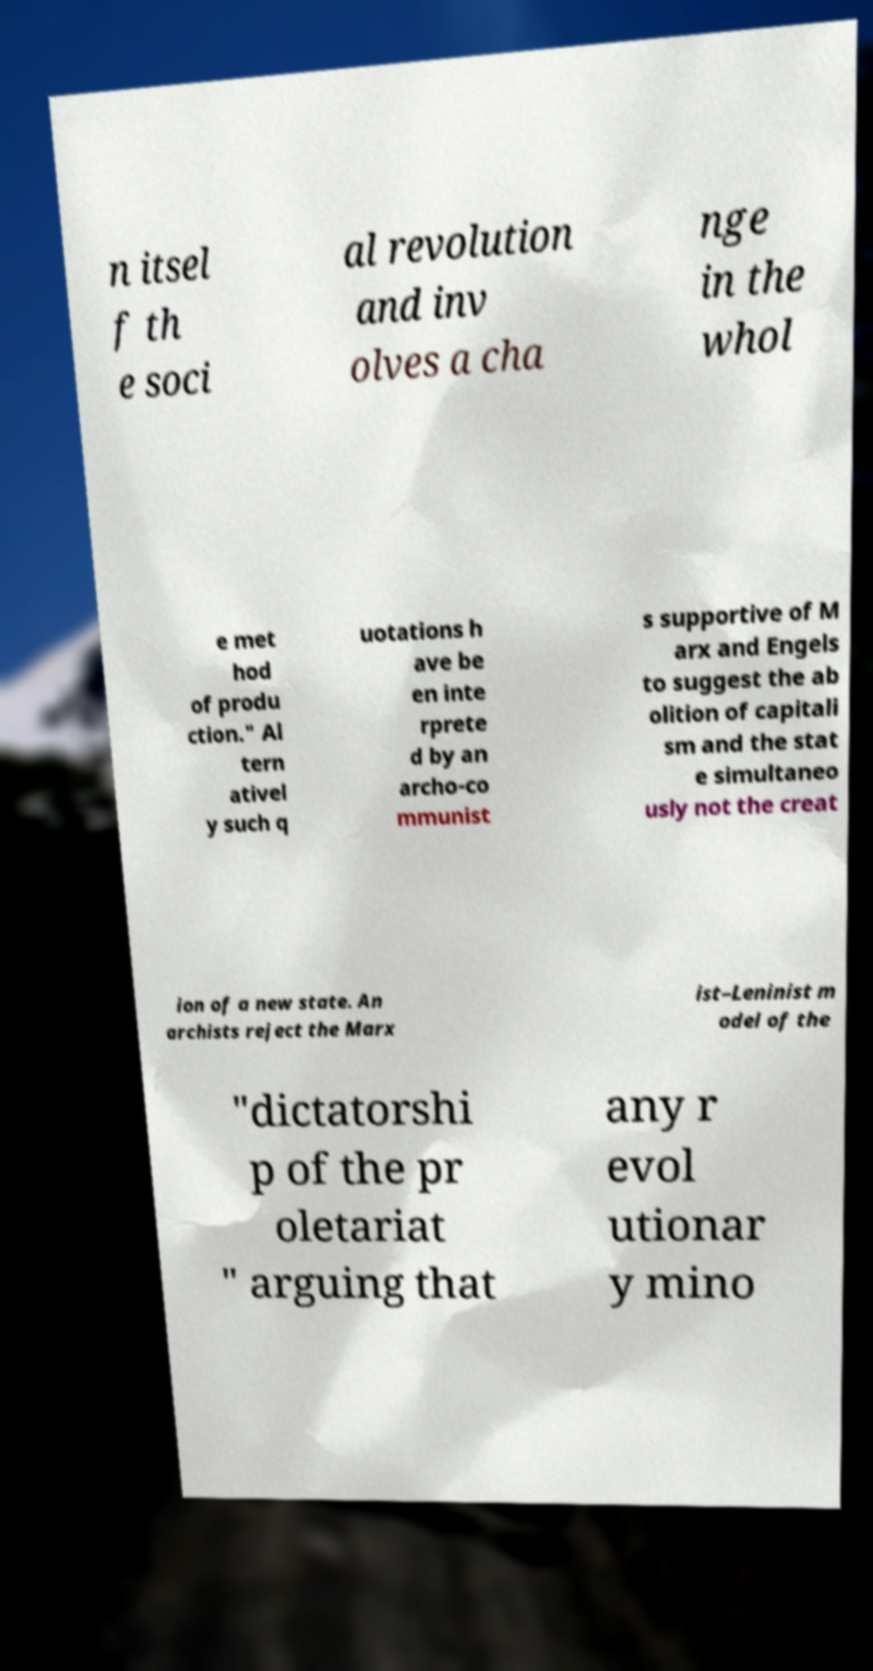Can you read and provide the text displayed in the image?This photo seems to have some interesting text. Can you extract and type it out for me? n itsel f th e soci al revolution and inv olves a cha nge in the whol e met hod of produ ction." Al tern ativel y such q uotations h ave be en inte rprete d by an archo-co mmunist s supportive of M arx and Engels to suggest the ab olition of capitali sm and the stat e simultaneo usly not the creat ion of a new state. An archists reject the Marx ist–Leninist m odel of the "dictatorshi p of the pr oletariat " arguing that any r evol utionar y mino 